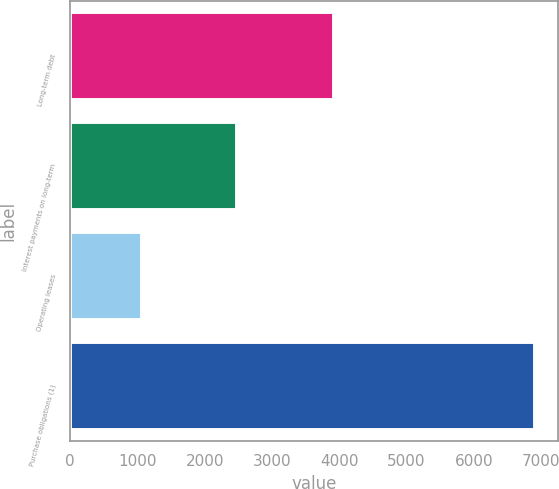Convert chart to OTSL. <chart><loc_0><loc_0><loc_500><loc_500><bar_chart><fcel>Long-term debt<fcel>Interest payments on long-term<fcel>Operating leases<fcel>Purchase obligations (1)<nl><fcel>3924<fcel>2485<fcel>1071<fcel>6907<nl></chart> 